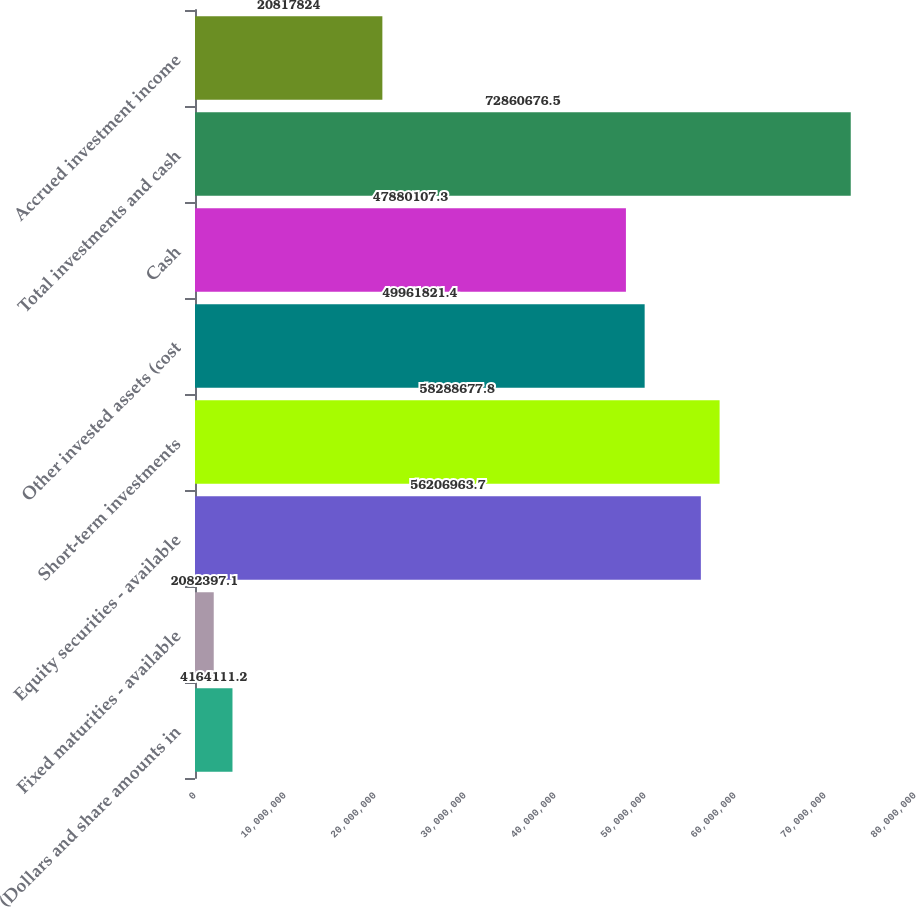Convert chart to OTSL. <chart><loc_0><loc_0><loc_500><loc_500><bar_chart><fcel>(Dollars and share amounts in<fcel>Fixed maturities - available<fcel>Equity securities - available<fcel>Short-term investments<fcel>Other invested assets (cost<fcel>Cash<fcel>Total investments and cash<fcel>Accrued investment income<nl><fcel>4.16411e+06<fcel>2.0824e+06<fcel>5.6207e+07<fcel>5.82887e+07<fcel>4.99618e+07<fcel>4.78801e+07<fcel>7.28607e+07<fcel>2.08178e+07<nl></chart> 